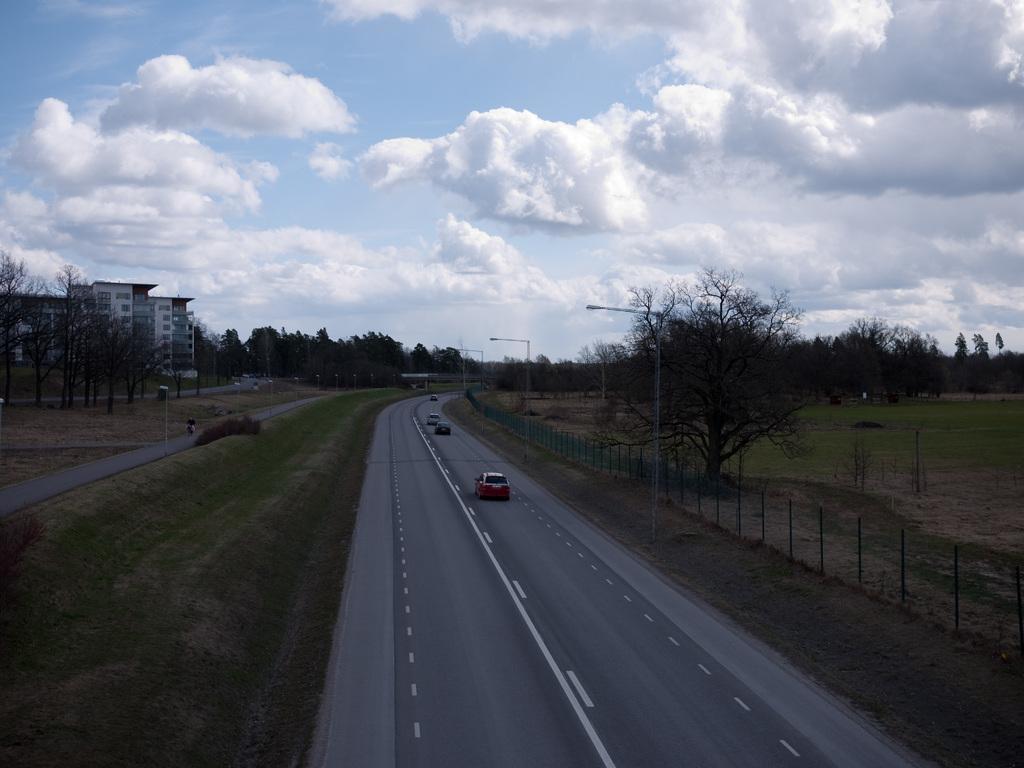Can you describe this image briefly? In this picture we can see many cars on the road. Beside that we can see street lights and fencing. On the left there is a building. Hear we can see many trees. On the bottom left corner we can see grass. On the top we can see sky and clouds. 